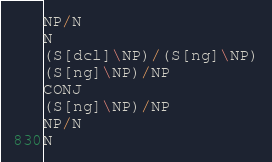Convert code to text. <code><loc_0><loc_0><loc_500><loc_500><_C_>NP/N
N
(S[dcl]\NP)/(S[ng]\NP)
(S[ng]\NP)/NP
CONJ
(S[ng]\NP)/NP
NP/N
N
</code> 